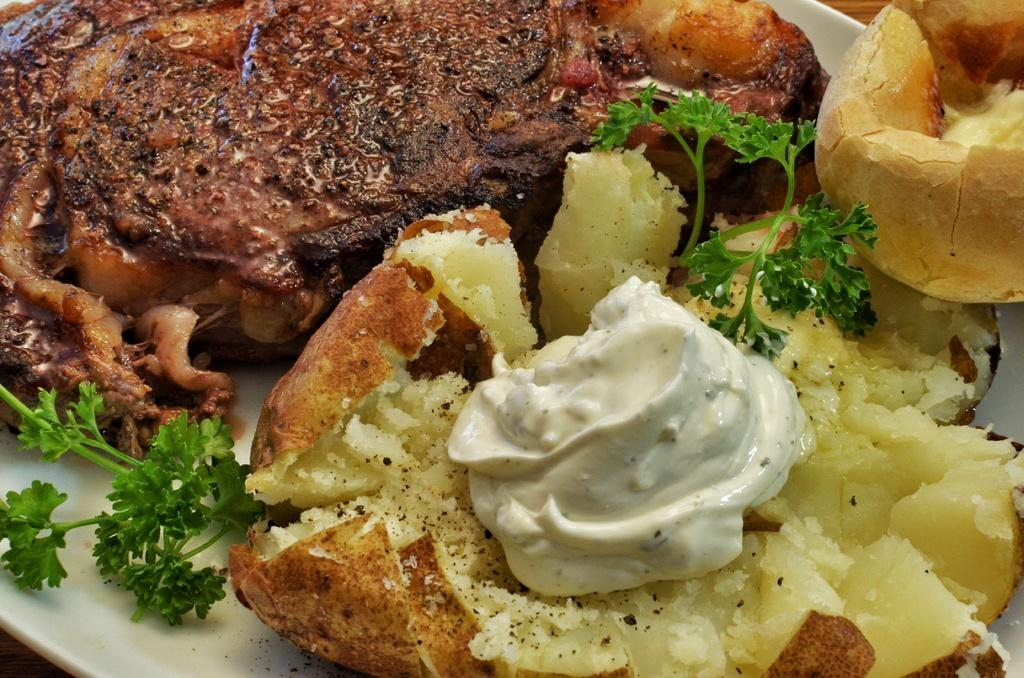What is the focus of the image? The image is a zoomed in picture. What can be seen in the zoomed in image? The image contains food items. How are the food items arranged in the image? The food items are present on a plate. What type of industry can be seen in the background of the image? There is no industry present in the image; it is a close-up of food items on a plate. Can you identify any steel components in the image? There are no steel components present in the image; it is a close-up of food items on a plate. 